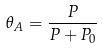Convert formula to latex. <formula><loc_0><loc_0><loc_500><loc_500>\theta _ { A } = \frac { P } { P + P _ { 0 } }</formula> 